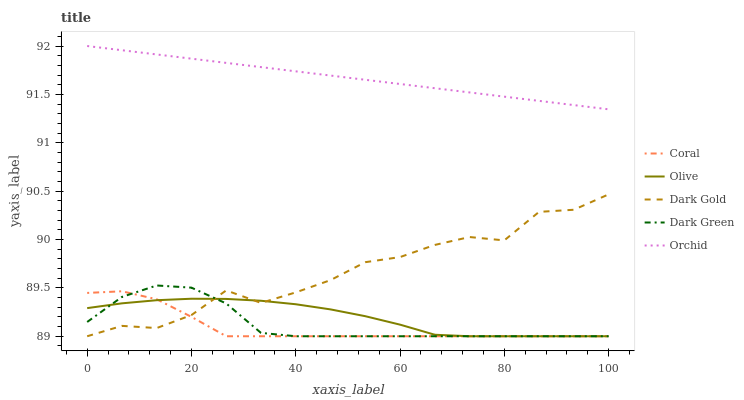Does Coral have the minimum area under the curve?
Answer yes or no. Yes. Does Dark Green have the minimum area under the curve?
Answer yes or no. No. Does Dark Green have the maximum area under the curve?
Answer yes or no. No. Is Coral the smoothest?
Answer yes or no. No. Is Coral the roughest?
Answer yes or no. No. Does Orchid have the lowest value?
Answer yes or no. No. Does Coral have the highest value?
Answer yes or no. No. Is Olive less than Orchid?
Answer yes or no. Yes. Is Orchid greater than Dark Gold?
Answer yes or no. Yes. Does Olive intersect Orchid?
Answer yes or no. No. 